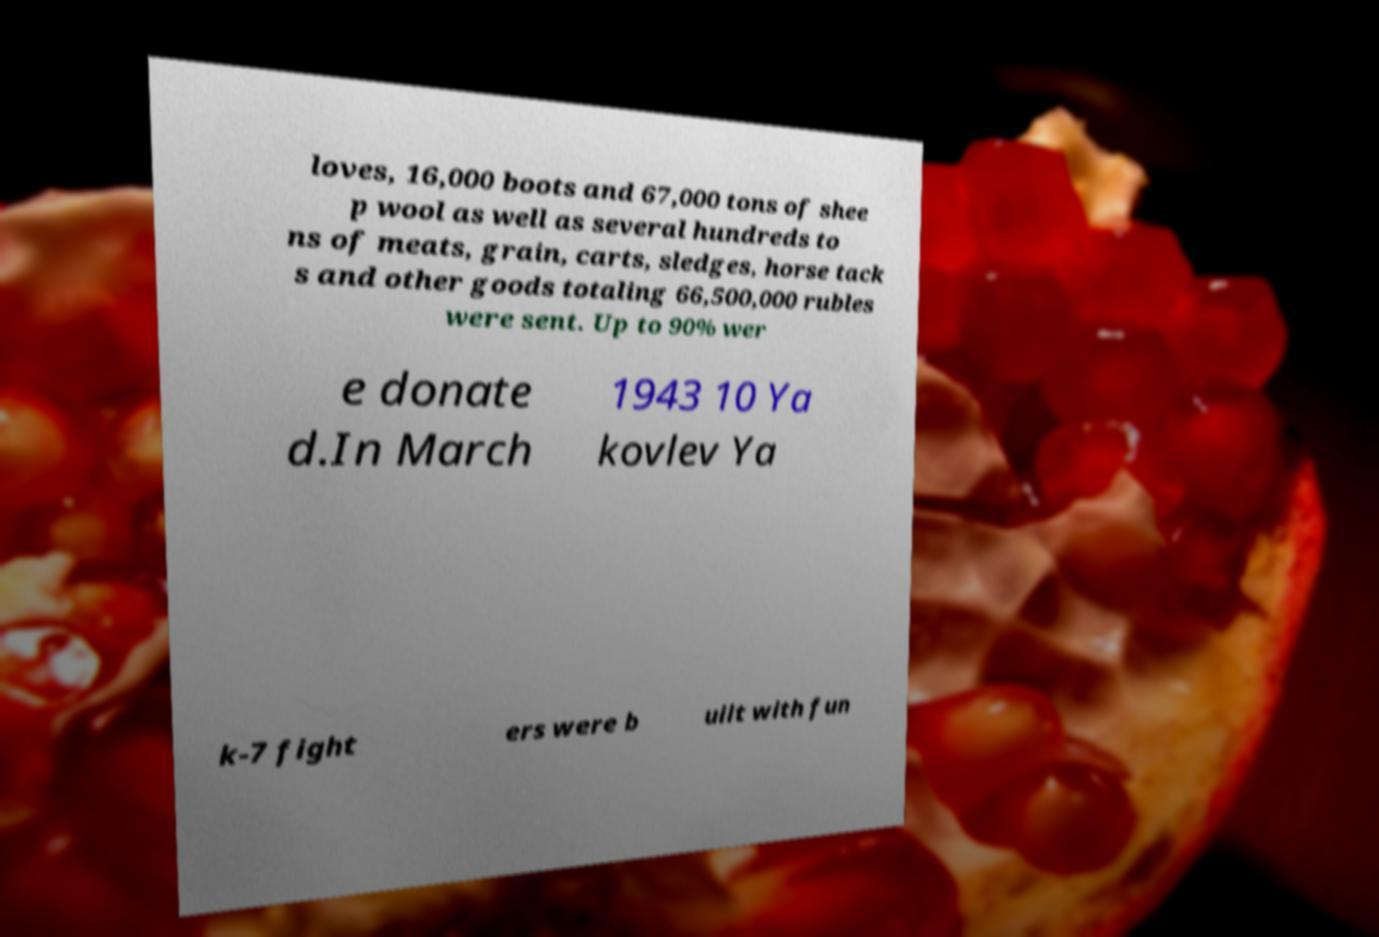There's text embedded in this image that I need extracted. Can you transcribe it verbatim? loves, 16,000 boots and 67,000 tons of shee p wool as well as several hundreds to ns of meats, grain, carts, sledges, horse tack s and other goods totaling 66,500,000 rubles were sent. Up to 90% wer e donate d.In March 1943 10 Ya kovlev Ya k-7 fight ers were b uilt with fun 